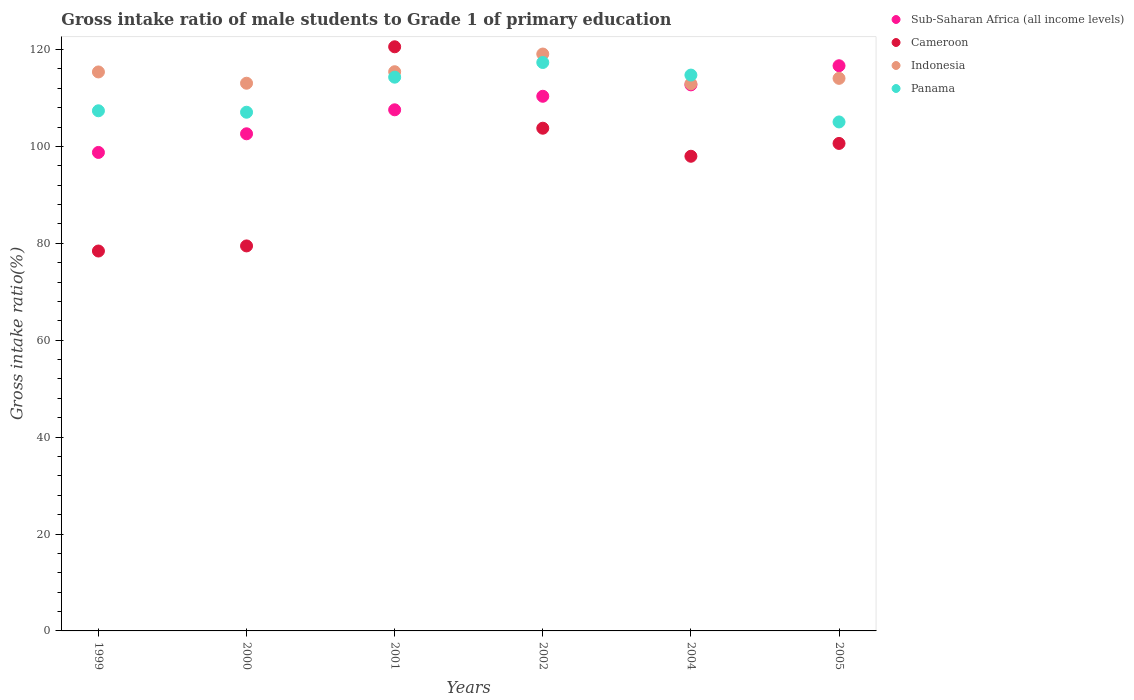How many different coloured dotlines are there?
Keep it short and to the point. 4. What is the gross intake ratio in Indonesia in 1999?
Offer a very short reply. 115.38. Across all years, what is the maximum gross intake ratio in Indonesia?
Make the answer very short. 119.08. Across all years, what is the minimum gross intake ratio in Cameroon?
Keep it short and to the point. 78.41. In which year was the gross intake ratio in Sub-Saharan Africa (all income levels) maximum?
Offer a terse response. 2005. In which year was the gross intake ratio in Sub-Saharan Africa (all income levels) minimum?
Ensure brevity in your answer.  1999. What is the total gross intake ratio in Panama in the graph?
Give a very brief answer. 665.84. What is the difference between the gross intake ratio in Indonesia in 2001 and that in 2005?
Your response must be concise. 1.37. What is the difference between the gross intake ratio in Cameroon in 2002 and the gross intake ratio in Panama in 2000?
Provide a short and direct response. -3.3. What is the average gross intake ratio in Sub-Saharan Africa (all income levels) per year?
Provide a succinct answer. 108.11. In the year 2000, what is the difference between the gross intake ratio in Cameroon and gross intake ratio in Panama?
Your answer should be compact. -27.6. What is the ratio of the gross intake ratio in Panama in 2001 to that in 2004?
Provide a short and direct response. 1. Is the gross intake ratio in Indonesia in 2002 less than that in 2005?
Ensure brevity in your answer.  No. Is the difference between the gross intake ratio in Cameroon in 2002 and 2005 greater than the difference between the gross intake ratio in Panama in 2002 and 2005?
Provide a short and direct response. No. What is the difference between the highest and the second highest gross intake ratio in Cameroon?
Provide a succinct answer. 16.81. What is the difference between the highest and the lowest gross intake ratio in Sub-Saharan Africa (all income levels)?
Ensure brevity in your answer.  17.89. In how many years, is the gross intake ratio in Sub-Saharan Africa (all income levels) greater than the average gross intake ratio in Sub-Saharan Africa (all income levels) taken over all years?
Make the answer very short. 3. Is it the case that in every year, the sum of the gross intake ratio in Panama and gross intake ratio in Cameroon  is greater than the sum of gross intake ratio in Sub-Saharan Africa (all income levels) and gross intake ratio in Indonesia?
Ensure brevity in your answer.  No. Is it the case that in every year, the sum of the gross intake ratio in Panama and gross intake ratio in Cameroon  is greater than the gross intake ratio in Indonesia?
Provide a short and direct response. Yes. Is the gross intake ratio in Cameroon strictly greater than the gross intake ratio in Sub-Saharan Africa (all income levels) over the years?
Offer a very short reply. No. Are the values on the major ticks of Y-axis written in scientific E-notation?
Keep it short and to the point. No. What is the title of the graph?
Offer a terse response. Gross intake ratio of male students to Grade 1 of primary education. Does "Chile" appear as one of the legend labels in the graph?
Your answer should be very brief. No. What is the label or title of the Y-axis?
Your answer should be compact. Gross intake ratio(%). What is the Gross intake ratio(%) in Sub-Saharan Africa (all income levels) in 1999?
Your answer should be compact. 98.76. What is the Gross intake ratio(%) of Cameroon in 1999?
Keep it short and to the point. 78.41. What is the Gross intake ratio(%) in Indonesia in 1999?
Your response must be concise. 115.38. What is the Gross intake ratio(%) in Panama in 1999?
Ensure brevity in your answer.  107.36. What is the Gross intake ratio(%) in Sub-Saharan Africa (all income levels) in 2000?
Your answer should be very brief. 102.61. What is the Gross intake ratio(%) in Cameroon in 2000?
Give a very brief answer. 79.47. What is the Gross intake ratio(%) of Indonesia in 2000?
Provide a short and direct response. 113.05. What is the Gross intake ratio(%) of Panama in 2000?
Your response must be concise. 107.06. What is the Gross intake ratio(%) of Sub-Saharan Africa (all income levels) in 2001?
Ensure brevity in your answer.  107.56. What is the Gross intake ratio(%) in Cameroon in 2001?
Your answer should be very brief. 120.57. What is the Gross intake ratio(%) in Indonesia in 2001?
Provide a succinct answer. 115.42. What is the Gross intake ratio(%) in Panama in 2001?
Offer a very short reply. 114.3. What is the Gross intake ratio(%) in Sub-Saharan Africa (all income levels) in 2002?
Ensure brevity in your answer.  110.36. What is the Gross intake ratio(%) in Cameroon in 2002?
Provide a short and direct response. 103.76. What is the Gross intake ratio(%) of Indonesia in 2002?
Keep it short and to the point. 119.08. What is the Gross intake ratio(%) of Panama in 2002?
Give a very brief answer. 117.33. What is the Gross intake ratio(%) in Sub-Saharan Africa (all income levels) in 2004?
Your response must be concise. 112.71. What is the Gross intake ratio(%) of Cameroon in 2004?
Your answer should be compact. 97.98. What is the Gross intake ratio(%) of Indonesia in 2004?
Ensure brevity in your answer.  112.94. What is the Gross intake ratio(%) in Panama in 2004?
Your response must be concise. 114.73. What is the Gross intake ratio(%) of Sub-Saharan Africa (all income levels) in 2005?
Offer a very short reply. 116.66. What is the Gross intake ratio(%) in Cameroon in 2005?
Your answer should be compact. 100.62. What is the Gross intake ratio(%) of Indonesia in 2005?
Make the answer very short. 114.06. What is the Gross intake ratio(%) in Panama in 2005?
Ensure brevity in your answer.  105.06. Across all years, what is the maximum Gross intake ratio(%) in Sub-Saharan Africa (all income levels)?
Your answer should be compact. 116.66. Across all years, what is the maximum Gross intake ratio(%) of Cameroon?
Your answer should be very brief. 120.57. Across all years, what is the maximum Gross intake ratio(%) in Indonesia?
Your answer should be very brief. 119.08. Across all years, what is the maximum Gross intake ratio(%) in Panama?
Ensure brevity in your answer.  117.33. Across all years, what is the minimum Gross intake ratio(%) of Sub-Saharan Africa (all income levels)?
Offer a very short reply. 98.76. Across all years, what is the minimum Gross intake ratio(%) of Cameroon?
Offer a terse response. 78.41. Across all years, what is the minimum Gross intake ratio(%) of Indonesia?
Give a very brief answer. 112.94. Across all years, what is the minimum Gross intake ratio(%) in Panama?
Offer a terse response. 105.06. What is the total Gross intake ratio(%) in Sub-Saharan Africa (all income levels) in the graph?
Offer a terse response. 648.66. What is the total Gross intake ratio(%) in Cameroon in the graph?
Provide a succinct answer. 580.81. What is the total Gross intake ratio(%) of Indonesia in the graph?
Your answer should be very brief. 689.92. What is the total Gross intake ratio(%) in Panama in the graph?
Provide a succinct answer. 665.84. What is the difference between the Gross intake ratio(%) of Sub-Saharan Africa (all income levels) in 1999 and that in 2000?
Offer a very short reply. -3.85. What is the difference between the Gross intake ratio(%) in Cameroon in 1999 and that in 2000?
Your response must be concise. -1.05. What is the difference between the Gross intake ratio(%) of Indonesia in 1999 and that in 2000?
Make the answer very short. 2.33. What is the difference between the Gross intake ratio(%) of Panama in 1999 and that in 2000?
Provide a short and direct response. 0.3. What is the difference between the Gross intake ratio(%) of Sub-Saharan Africa (all income levels) in 1999 and that in 2001?
Make the answer very short. -8.8. What is the difference between the Gross intake ratio(%) in Cameroon in 1999 and that in 2001?
Make the answer very short. -42.16. What is the difference between the Gross intake ratio(%) of Indonesia in 1999 and that in 2001?
Your answer should be very brief. -0.05. What is the difference between the Gross intake ratio(%) in Panama in 1999 and that in 2001?
Offer a terse response. -6.94. What is the difference between the Gross intake ratio(%) in Sub-Saharan Africa (all income levels) in 1999 and that in 2002?
Give a very brief answer. -11.59. What is the difference between the Gross intake ratio(%) of Cameroon in 1999 and that in 2002?
Your response must be concise. -25.35. What is the difference between the Gross intake ratio(%) in Indonesia in 1999 and that in 2002?
Provide a succinct answer. -3.7. What is the difference between the Gross intake ratio(%) in Panama in 1999 and that in 2002?
Offer a terse response. -9.97. What is the difference between the Gross intake ratio(%) of Sub-Saharan Africa (all income levels) in 1999 and that in 2004?
Make the answer very short. -13.95. What is the difference between the Gross intake ratio(%) in Cameroon in 1999 and that in 2004?
Keep it short and to the point. -19.56. What is the difference between the Gross intake ratio(%) of Indonesia in 1999 and that in 2004?
Provide a succinct answer. 2.44. What is the difference between the Gross intake ratio(%) of Panama in 1999 and that in 2004?
Your answer should be very brief. -7.37. What is the difference between the Gross intake ratio(%) in Sub-Saharan Africa (all income levels) in 1999 and that in 2005?
Provide a short and direct response. -17.89. What is the difference between the Gross intake ratio(%) in Cameroon in 1999 and that in 2005?
Provide a short and direct response. -22.21. What is the difference between the Gross intake ratio(%) in Indonesia in 1999 and that in 2005?
Offer a very short reply. 1.32. What is the difference between the Gross intake ratio(%) of Panama in 1999 and that in 2005?
Offer a terse response. 2.31. What is the difference between the Gross intake ratio(%) in Sub-Saharan Africa (all income levels) in 2000 and that in 2001?
Offer a terse response. -4.95. What is the difference between the Gross intake ratio(%) of Cameroon in 2000 and that in 2001?
Provide a short and direct response. -41.1. What is the difference between the Gross intake ratio(%) of Indonesia in 2000 and that in 2001?
Your answer should be very brief. -2.37. What is the difference between the Gross intake ratio(%) of Panama in 2000 and that in 2001?
Ensure brevity in your answer.  -7.24. What is the difference between the Gross intake ratio(%) of Sub-Saharan Africa (all income levels) in 2000 and that in 2002?
Make the answer very short. -7.74. What is the difference between the Gross intake ratio(%) of Cameroon in 2000 and that in 2002?
Offer a terse response. -24.3. What is the difference between the Gross intake ratio(%) in Indonesia in 2000 and that in 2002?
Keep it short and to the point. -6.03. What is the difference between the Gross intake ratio(%) in Panama in 2000 and that in 2002?
Your answer should be very brief. -10.27. What is the difference between the Gross intake ratio(%) of Sub-Saharan Africa (all income levels) in 2000 and that in 2004?
Offer a very short reply. -10.1. What is the difference between the Gross intake ratio(%) in Cameroon in 2000 and that in 2004?
Give a very brief answer. -18.51. What is the difference between the Gross intake ratio(%) of Indonesia in 2000 and that in 2004?
Your answer should be compact. 0.11. What is the difference between the Gross intake ratio(%) of Panama in 2000 and that in 2004?
Give a very brief answer. -7.67. What is the difference between the Gross intake ratio(%) of Sub-Saharan Africa (all income levels) in 2000 and that in 2005?
Your response must be concise. -14.04. What is the difference between the Gross intake ratio(%) of Cameroon in 2000 and that in 2005?
Give a very brief answer. -21.15. What is the difference between the Gross intake ratio(%) of Indonesia in 2000 and that in 2005?
Provide a short and direct response. -1.01. What is the difference between the Gross intake ratio(%) in Panama in 2000 and that in 2005?
Keep it short and to the point. 2.01. What is the difference between the Gross intake ratio(%) of Sub-Saharan Africa (all income levels) in 2001 and that in 2002?
Keep it short and to the point. -2.79. What is the difference between the Gross intake ratio(%) in Cameroon in 2001 and that in 2002?
Your response must be concise. 16.81. What is the difference between the Gross intake ratio(%) in Indonesia in 2001 and that in 2002?
Your response must be concise. -3.65. What is the difference between the Gross intake ratio(%) of Panama in 2001 and that in 2002?
Make the answer very short. -3.03. What is the difference between the Gross intake ratio(%) in Sub-Saharan Africa (all income levels) in 2001 and that in 2004?
Provide a short and direct response. -5.15. What is the difference between the Gross intake ratio(%) of Cameroon in 2001 and that in 2004?
Give a very brief answer. 22.6. What is the difference between the Gross intake ratio(%) in Indonesia in 2001 and that in 2004?
Give a very brief answer. 2.48. What is the difference between the Gross intake ratio(%) in Panama in 2001 and that in 2004?
Your answer should be very brief. -0.43. What is the difference between the Gross intake ratio(%) in Sub-Saharan Africa (all income levels) in 2001 and that in 2005?
Provide a succinct answer. -9.09. What is the difference between the Gross intake ratio(%) in Cameroon in 2001 and that in 2005?
Your answer should be very brief. 19.95. What is the difference between the Gross intake ratio(%) in Indonesia in 2001 and that in 2005?
Your answer should be compact. 1.37. What is the difference between the Gross intake ratio(%) in Panama in 2001 and that in 2005?
Your response must be concise. 9.24. What is the difference between the Gross intake ratio(%) in Sub-Saharan Africa (all income levels) in 2002 and that in 2004?
Ensure brevity in your answer.  -2.35. What is the difference between the Gross intake ratio(%) of Cameroon in 2002 and that in 2004?
Provide a short and direct response. 5.79. What is the difference between the Gross intake ratio(%) of Indonesia in 2002 and that in 2004?
Provide a succinct answer. 6.14. What is the difference between the Gross intake ratio(%) in Panama in 2002 and that in 2004?
Ensure brevity in your answer.  2.6. What is the difference between the Gross intake ratio(%) in Sub-Saharan Africa (all income levels) in 2002 and that in 2005?
Give a very brief answer. -6.3. What is the difference between the Gross intake ratio(%) of Cameroon in 2002 and that in 2005?
Provide a succinct answer. 3.14. What is the difference between the Gross intake ratio(%) of Indonesia in 2002 and that in 2005?
Keep it short and to the point. 5.02. What is the difference between the Gross intake ratio(%) of Panama in 2002 and that in 2005?
Give a very brief answer. 12.27. What is the difference between the Gross intake ratio(%) of Sub-Saharan Africa (all income levels) in 2004 and that in 2005?
Make the answer very short. -3.95. What is the difference between the Gross intake ratio(%) in Cameroon in 2004 and that in 2005?
Ensure brevity in your answer.  -2.65. What is the difference between the Gross intake ratio(%) in Indonesia in 2004 and that in 2005?
Provide a short and direct response. -1.12. What is the difference between the Gross intake ratio(%) in Panama in 2004 and that in 2005?
Your answer should be compact. 9.67. What is the difference between the Gross intake ratio(%) in Sub-Saharan Africa (all income levels) in 1999 and the Gross intake ratio(%) in Cameroon in 2000?
Offer a terse response. 19.3. What is the difference between the Gross intake ratio(%) in Sub-Saharan Africa (all income levels) in 1999 and the Gross intake ratio(%) in Indonesia in 2000?
Make the answer very short. -14.29. What is the difference between the Gross intake ratio(%) in Sub-Saharan Africa (all income levels) in 1999 and the Gross intake ratio(%) in Panama in 2000?
Provide a succinct answer. -8.3. What is the difference between the Gross intake ratio(%) of Cameroon in 1999 and the Gross intake ratio(%) of Indonesia in 2000?
Make the answer very short. -34.64. What is the difference between the Gross intake ratio(%) in Cameroon in 1999 and the Gross intake ratio(%) in Panama in 2000?
Keep it short and to the point. -28.65. What is the difference between the Gross intake ratio(%) in Indonesia in 1999 and the Gross intake ratio(%) in Panama in 2000?
Provide a succinct answer. 8.31. What is the difference between the Gross intake ratio(%) of Sub-Saharan Africa (all income levels) in 1999 and the Gross intake ratio(%) of Cameroon in 2001?
Provide a succinct answer. -21.81. What is the difference between the Gross intake ratio(%) in Sub-Saharan Africa (all income levels) in 1999 and the Gross intake ratio(%) in Indonesia in 2001?
Provide a succinct answer. -16.66. What is the difference between the Gross intake ratio(%) in Sub-Saharan Africa (all income levels) in 1999 and the Gross intake ratio(%) in Panama in 2001?
Offer a terse response. -15.53. What is the difference between the Gross intake ratio(%) in Cameroon in 1999 and the Gross intake ratio(%) in Indonesia in 2001?
Give a very brief answer. -37.01. What is the difference between the Gross intake ratio(%) of Cameroon in 1999 and the Gross intake ratio(%) of Panama in 2001?
Give a very brief answer. -35.88. What is the difference between the Gross intake ratio(%) of Indonesia in 1999 and the Gross intake ratio(%) of Panama in 2001?
Give a very brief answer. 1.08. What is the difference between the Gross intake ratio(%) in Sub-Saharan Africa (all income levels) in 1999 and the Gross intake ratio(%) in Cameroon in 2002?
Your response must be concise. -5. What is the difference between the Gross intake ratio(%) of Sub-Saharan Africa (all income levels) in 1999 and the Gross intake ratio(%) of Indonesia in 2002?
Your answer should be compact. -20.31. What is the difference between the Gross intake ratio(%) of Sub-Saharan Africa (all income levels) in 1999 and the Gross intake ratio(%) of Panama in 2002?
Make the answer very short. -18.56. What is the difference between the Gross intake ratio(%) in Cameroon in 1999 and the Gross intake ratio(%) in Indonesia in 2002?
Your answer should be compact. -40.66. What is the difference between the Gross intake ratio(%) in Cameroon in 1999 and the Gross intake ratio(%) in Panama in 2002?
Offer a terse response. -38.91. What is the difference between the Gross intake ratio(%) in Indonesia in 1999 and the Gross intake ratio(%) in Panama in 2002?
Provide a short and direct response. -1.95. What is the difference between the Gross intake ratio(%) of Sub-Saharan Africa (all income levels) in 1999 and the Gross intake ratio(%) of Cameroon in 2004?
Your response must be concise. 0.79. What is the difference between the Gross intake ratio(%) of Sub-Saharan Africa (all income levels) in 1999 and the Gross intake ratio(%) of Indonesia in 2004?
Your answer should be compact. -14.17. What is the difference between the Gross intake ratio(%) of Sub-Saharan Africa (all income levels) in 1999 and the Gross intake ratio(%) of Panama in 2004?
Keep it short and to the point. -15.97. What is the difference between the Gross intake ratio(%) of Cameroon in 1999 and the Gross intake ratio(%) of Indonesia in 2004?
Ensure brevity in your answer.  -34.52. What is the difference between the Gross intake ratio(%) in Cameroon in 1999 and the Gross intake ratio(%) in Panama in 2004?
Your response must be concise. -36.32. What is the difference between the Gross intake ratio(%) of Indonesia in 1999 and the Gross intake ratio(%) of Panama in 2004?
Offer a terse response. 0.65. What is the difference between the Gross intake ratio(%) in Sub-Saharan Africa (all income levels) in 1999 and the Gross intake ratio(%) in Cameroon in 2005?
Make the answer very short. -1.86. What is the difference between the Gross intake ratio(%) of Sub-Saharan Africa (all income levels) in 1999 and the Gross intake ratio(%) of Indonesia in 2005?
Give a very brief answer. -15.29. What is the difference between the Gross intake ratio(%) in Sub-Saharan Africa (all income levels) in 1999 and the Gross intake ratio(%) in Panama in 2005?
Your response must be concise. -6.29. What is the difference between the Gross intake ratio(%) of Cameroon in 1999 and the Gross intake ratio(%) of Indonesia in 2005?
Provide a succinct answer. -35.64. What is the difference between the Gross intake ratio(%) in Cameroon in 1999 and the Gross intake ratio(%) in Panama in 2005?
Give a very brief answer. -26.64. What is the difference between the Gross intake ratio(%) in Indonesia in 1999 and the Gross intake ratio(%) in Panama in 2005?
Your answer should be compact. 10.32. What is the difference between the Gross intake ratio(%) of Sub-Saharan Africa (all income levels) in 2000 and the Gross intake ratio(%) of Cameroon in 2001?
Make the answer very short. -17.96. What is the difference between the Gross intake ratio(%) in Sub-Saharan Africa (all income levels) in 2000 and the Gross intake ratio(%) in Indonesia in 2001?
Provide a succinct answer. -12.81. What is the difference between the Gross intake ratio(%) of Sub-Saharan Africa (all income levels) in 2000 and the Gross intake ratio(%) of Panama in 2001?
Your answer should be very brief. -11.68. What is the difference between the Gross intake ratio(%) in Cameroon in 2000 and the Gross intake ratio(%) in Indonesia in 2001?
Offer a terse response. -35.95. What is the difference between the Gross intake ratio(%) in Cameroon in 2000 and the Gross intake ratio(%) in Panama in 2001?
Ensure brevity in your answer.  -34.83. What is the difference between the Gross intake ratio(%) of Indonesia in 2000 and the Gross intake ratio(%) of Panama in 2001?
Provide a short and direct response. -1.25. What is the difference between the Gross intake ratio(%) in Sub-Saharan Africa (all income levels) in 2000 and the Gross intake ratio(%) in Cameroon in 2002?
Ensure brevity in your answer.  -1.15. What is the difference between the Gross intake ratio(%) of Sub-Saharan Africa (all income levels) in 2000 and the Gross intake ratio(%) of Indonesia in 2002?
Keep it short and to the point. -16.46. What is the difference between the Gross intake ratio(%) of Sub-Saharan Africa (all income levels) in 2000 and the Gross intake ratio(%) of Panama in 2002?
Offer a very short reply. -14.71. What is the difference between the Gross intake ratio(%) of Cameroon in 2000 and the Gross intake ratio(%) of Indonesia in 2002?
Provide a succinct answer. -39.61. What is the difference between the Gross intake ratio(%) in Cameroon in 2000 and the Gross intake ratio(%) in Panama in 2002?
Your answer should be compact. -37.86. What is the difference between the Gross intake ratio(%) of Indonesia in 2000 and the Gross intake ratio(%) of Panama in 2002?
Offer a terse response. -4.28. What is the difference between the Gross intake ratio(%) of Sub-Saharan Africa (all income levels) in 2000 and the Gross intake ratio(%) of Cameroon in 2004?
Offer a very short reply. 4.64. What is the difference between the Gross intake ratio(%) in Sub-Saharan Africa (all income levels) in 2000 and the Gross intake ratio(%) in Indonesia in 2004?
Your response must be concise. -10.32. What is the difference between the Gross intake ratio(%) of Sub-Saharan Africa (all income levels) in 2000 and the Gross intake ratio(%) of Panama in 2004?
Offer a terse response. -12.12. What is the difference between the Gross intake ratio(%) of Cameroon in 2000 and the Gross intake ratio(%) of Indonesia in 2004?
Provide a succinct answer. -33.47. What is the difference between the Gross intake ratio(%) in Cameroon in 2000 and the Gross intake ratio(%) in Panama in 2004?
Your response must be concise. -35.26. What is the difference between the Gross intake ratio(%) of Indonesia in 2000 and the Gross intake ratio(%) of Panama in 2004?
Provide a short and direct response. -1.68. What is the difference between the Gross intake ratio(%) of Sub-Saharan Africa (all income levels) in 2000 and the Gross intake ratio(%) of Cameroon in 2005?
Your response must be concise. 1.99. What is the difference between the Gross intake ratio(%) in Sub-Saharan Africa (all income levels) in 2000 and the Gross intake ratio(%) in Indonesia in 2005?
Offer a very short reply. -11.44. What is the difference between the Gross intake ratio(%) of Sub-Saharan Africa (all income levels) in 2000 and the Gross intake ratio(%) of Panama in 2005?
Keep it short and to the point. -2.44. What is the difference between the Gross intake ratio(%) of Cameroon in 2000 and the Gross intake ratio(%) of Indonesia in 2005?
Offer a terse response. -34.59. What is the difference between the Gross intake ratio(%) in Cameroon in 2000 and the Gross intake ratio(%) in Panama in 2005?
Provide a succinct answer. -25.59. What is the difference between the Gross intake ratio(%) in Indonesia in 2000 and the Gross intake ratio(%) in Panama in 2005?
Offer a very short reply. 7.99. What is the difference between the Gross intake ratio(%) of Sub-Saharan Africa (all income levels) in 2001 and the Gross intake ratio(%) of Cameroon in 2002?
Your answer should be very brief. 3.8. What is the difference between the Gross intake ratio(%) of Sub-Saharan Africa (all income levels) in 2001 and the Gross intake ratio(%) of Indonesia in 2002?
Your answer should be compact. -11.51. What is the difference between the Gross intake ratio(%) in Sub-Saharan Africa (all income levels) in 2001 and the Gross intake ratio(%) in Panama in 2002?
Give a very brief answer. -9.77. What is the difference between the Gross intake ratio(%) of Cameroon in 2001 and the Gross intake ratio(%) of Indonesia in 2002?
Provide a succinct answer. 1.5. What is the difference between the Gross intake ratio(%) of Cameroon in 2001 and the Gross intake ratio(%) of Panama in 2002?
Your answer should be very brief. 3.24. What is the difference between the Gross intake ratio(%) of Indonesia in 2001 and the Gross intake ratio(%) of Panama in 2002?
Keep it short and to the point. -1.91. What is the difference between the Gross intake ratio(%) of Sub-Saharan Africa (all income levels) in 2001 and the Gross intake ratio(%) of Cameroon in 2004?
Your answer should be compact. 9.59. What is the difference between the Gross intake ratio(%) in Sub-Saharan Africa (all income levels) in 2001 and the Gross intake ratio(%) in Indonesia in 2004?
Your answer should be very brief. -5.37. What is the difference between the Gross intake ratio(%) of Sub-Saharan Africa (all income levels) in 2001 and the Gross intake ratio(%) of Panama in 2004?
Provide a succinct answer. -7.17. What is the difference between the Gross intake ratio(%) of Cameroon in 2001 and the Gross intake ratio(%) of Indonesia in 2004?
Keep it short and to the point. 7.63. What is the difference between the Gross intake ratio(%) in Cameroon in 2001 and the Gross intake ratio(%) in Panama in 2004?
Provide a succinct answer. 5.84. What is the difference between the Gross intake ratio(%) in Indonesia in 2001 and the Gross intake ratio(%) in Panama in 2004?
Offer a very short reply. 0.69. What is the difference between the Gross intake ratio(%) in Sub-Saharan Africa (all income levels) in 2001 and the Gross intake ratio(%) in Cameroon in 2005?
Make the answer very short. 6.94. What is the difference between the Gross intake ratio(%) in Sub-Saharan Africa (all income levels) in 2001 and the Gross intake ratio(%) in Indonesia in 2005?
Keep it short and to the point. -6.49. What is the difference between the Gross intake ratio(%) of Sub-Saharan Africa (all income levels) in 2001 and the Gross intake ratio(%) of Panama in 2005?
Your answer should be compact. 2.51. What is the difference between the Gross intake ratio(%) of Cameroon in 2001 and the Gross intake ratio(%) of Indonesia in 2005?
Keep it short and to the point. 6.52. What is the difference between the Gross intake ratio(%) in Cameroon in 2001 and the Gross intake ratio(%) in Panama in 2005?
Your response must be concise. 15.51. What is the difference between the Gross intake ratio(%) of Indonesia in 2001 and the Gross intake ratio(%) of Panama in 2005?
Your answer should be very brief. 10.37. What is the difference between the Gross intake ratio(%) in Sub-Saharan Africa (all income levels) in 2002 and the Gross intake ratio(%) in Cameroon in 2004?
Give a very brief answer. 12.38. What is the difference between the Gross intake ratio(%) in Sub-Saharan Africa (all income levels) in 2002 and the Gross intake ratio(%) in Indonesia in 2004?
Give a very brief answer. -2.58. What is the difference between the Gross intake ratio(%) in Sub-Saharan Africa (all income levels) in 2002 and the Gross intake ratio(%) in Panama in 2004?
Offer a terse response. -4.37. What is the difference between the Gross intake ratio(%) in Cameroon in 2002 and the Gross intake ratio(%) in Indonesia in 2004?
Ensure brevity in your answer.  -9.17. What is the difference between the Gross intake ratio(%) of Cameroon in 2002 and the Gross intake ratio(%) of Panama in 2004?
Your answer should be compact. -10.97. What is the difference between the Gross intake ratio(%) in Indonesia in 2002 and the Gross intake ratio(%) in Panama in 2004?
Your answer should be compact. 4.34. What is the difference between the Gross intake ratio(%) of Sub-Saharan Africa (all income levels) in 2002 and the Gross intake ratio(%) of Cameroon in 2005?
Your answer should be compact. 9.73. What is the difference between the Gross intake ratio(%) of Sub-Saharan Africa (all income levels) in 2002 and the Gross intake ratio(%) of Indonesia in 2005?
Offer a very short reply. -3.7. What is the difference between the Gross intake ratio(%) of Sub-Saharan Africa (all income levels) in 2002 and the Gross intake ratio(%) of Panama in 2005?
Ensure brevity in your answer.  5.3. What is the difference between the Gross intake ratio(%) of Cameroon in 2002 and the Gross intake ratio(%) of Indonesia in 2005?
Your response must be concise. -10.29. What is the difference between the Gross intake ratio(%) of Cameroon in 2002 and the Gross intake ratio(%) of Panama in 2005?
Ensure brevity in your answer.  -1.29. What is the difference between the Gross intake ratio(%) of Indonesia in 2002 and the Gross intake ratio(%) of Panama in 2005?
Offer a terse response. 14.02. What is the difference between the Gross intake ratio(%) in Sub-Saharan Africa (all income levels) in 2004 and the Gross intake ratio(%) in Cameroon in 2005?
Make the answer very short. 12.09. What is the difference between the Gross intake ratio(%) in Sub-Saharan Africa (all income levels) in 2004 and the Gross intake ratio(%) in Indonesia in 2005?
Your answer should be compact. -1.35. What is the difference between the Gross intake ratio(%) of Sub-Saharan Africa (all income levels) in 2004 and the Gross intake ratio(%) of Panama in 2005?
Your response must be concise. 7.65. What is the difference between the Gross intake ratio(%) of Cameroon in 2004 and the Gross intake ratio(%) of Indonesia in 2005?
Offer a terse response. -16.08. What is the difference between the Gross intake ratio(%) of Cameroon in 2004 and the Gross intake ratio(%) of Panama in 2005?
Ensure brevity in your answer.  -7.08. What is the difference between the Gross intake ratio(%) of Indonesia in 2004 and the Gross intake ratio(%) of Panama in 2005?
Keep it short and to the point. 7.88. What is the average Gross intake ratio(%) of Sub-Saharan Africa (all income levels) per year?
Make the answer very short. 108.11. What is the average Gross intake ratio(%) in Cameroon per year?
Ensure brevity in your answer.  96.8. What is the average Gross intake ratio(%) in Indonesia per year?
Keep it short and to the point. 114.99. What is the average Gross intake ratio(%) of Panama per year?
Your response must be concise. 110.97. In the year 1999, what is the difference between the Gross intake ratio(%) in Sub-Saharan Africa (all income levels) and Gross intake ratio(%) in Cameroon?
Your response must be concise. 20.35. In the year 1999, what is the difference between the Gross intake ratio(%) in Sub-Saharan Africa (all income levels) and Gross intake ratio(%) in Indonesia?
Keep it short and to the point. -16.61. In the year 1999, what is the difference between the Gross intake ratio(%) of Sub-Saharan Africa (all income levels) and Gross intake ratio(%) of Panama?
Keep it short and to the point. -8.6. In the year 1999, what is the difference between the Gross intake ratio(%) of Cameroon and Gross intake ratio(%) of Indonesia?
Keep it short and to the point. -36.96. In the year 1999, what is the difference between the Gross intake ratio(%) of Cameroon and Gross intake ratio(%) of Panama?
Ensure brevity in your answer.  -28.95. In the year 1999, what is the difference between the Gross intake ratio(%) of Indonesia and Gross intake ratio(%) of Panama?
Ensure brevity in your answer.  8.02. In the year 2000, what is the difference between the Gross intake ratio(%) in Sub-Saharan Africa (all income levels) and Gross intake ratio(%) in Cameroon?
Offer a very short reply. 23.15. In the year 2000, what is the difference between the Gross intake ratio(%) of Sub-Saharan Africa (all income levels) and Gross intake ratio(%) of Indonesia?
Give a very brief answer. -10.44. In the year 2000, what is the difference between the Gross intake ratio(%) of Sub-Saharan Africa (all income levels) and Gross intake ratio(%) of Panama?
Keep it short and to the point. -4.45. In the year 2000, what is the difference between the Gross intake ratio(%) of Cameroon and Gross intake ratio(%) of Indonesia?
Your response must be concise. -33.58. In the year 2000, what is the difference between the Gross intake ratio(%) of Cameroon and Gross intake ratio(%) of Panama?
Provide a short and direct response. -27.6. In the year 2000, what is the difference between the Gross intake ratio(%) in Indonesia and Gross intake ratio(%) in Panama?
Keep it short and to the point. 5.99. In the year 2001, what is the difference between the Gross intake ratio(%) of Sub-Saharan Africa (all income levels) and Gross intake ratio(%) of Cameroon?
Give a very brief answer. -13.01. In the year 2001, what is the difference between the Gross intake ratio(%) in Sub-Saharan Africa (all income levels) and Gross intake ratio(%) in Indonesia?
Give a very brief answer. -7.86. In the year 2001, what is the difference between the Gross intake ratio(%) in Sub-Saharan Africa (all income levels) and Gross intake ratio(%) in Panama?
Offer a terse response. -6.74. In the year 2001, what is the difference between the Gross intake ratio(%) of Cameroon and Gross intake ratio(%) of Indonesia?
Offer a terse response. 5.15. In the year 2001, what is the difference between the Gross intake ratio(%) of Cameroon and Gross intake ratio(%) of Panama?
Keep it short and to the point. 6.27. In the year 2001, what is the difference between the Gross intake ratio(%) in Indonesia and Gross intake ratio(%) in Panama?
Make the answer very short. 1.12. In the year 2002, what is the difference between the Gross intake ratio(%) of Sub-Saharan Africa (all income levels) and Gross intake ratio(%) of Cameroon?
Make the answer very short. 6.59. In the year 2002, what is the difference between the Gross intake ratio(%) in Sub-Saharan Africa (all income levels) and Gross intake ratio(%) in Indonesia?
Your response must be concise. -8.72. In the year 2002, what is the difference between the Gross intake ratio(%) in Sub-Saharan Africa (all income levels) and Gross intake ratio(%) in Panama?
Your answer should be compact. -6.97. In the year 2002, what is the difference between the Gross intake ratio(%) in Cameroon and Gross intake ratio(%) in Indonesia?
Your answer should be compact. -15.31. In the year 2002, what is the difference between the Gross intake ratio(%) of Cameroon and Gross intake ratio(%) of Panama?
Your answer should be compact. -13.56. In the year 2002, what is the difference between the Gross intake ratio(%) of Indonesia and Gross intake ratio(%) of Panama?
Provide a succinct answer. 1.75. In the year 2004, what is the difference between the Gross intake ratio(%) of Sub-Saharan Africa (all income levels) and Gross intake ratio(%) of Cameroon?
Offer a very short reply. 14.73. In the year 2004, what is the difference between the Gross intake ratio(%) in Sub-Saharan Africa (all income levels) and Gross intake ratio(%) in Indonesia?
Provide a short and direct response. -0.23. In the year 2004, what is the difference between the Gross intake ratio(%) in Sub-Saharan Africa (all income levels) and Gross intake ratio(%) in Panama?
Offer a very short reply. -2.02. In the year 2004, what is the difference between the Gross intake ratio(%) in Cameroon and Gross intake ratio(%) in Indonesia?
Ensure brevity in your answer.  -14.96. In the year 2004, what is the difference between the Gross intake ratio(%) in Cameroon and Gross intake ratio(%) in Panama?
Your answer should be compact. -16.76. In the year 2004, what is the difference between the Gross intake ratio(%) of Indonesia and Gross intake ratio(%) of Panama?
Give a very brief answer. -1.79. In the year 2005, what is the difference between the Gross intake ratio(%) of Sub-Saharan Africa (all income levels) and Gross intake ratio(%) of Cameroon?
Your answer should be very brief. 16.03. In the year 2005, what is the difference between the Gross intake ratio(%) in Sub-Saharan Africa (all income levels) and Gross intake ratio(%) in Indonesia?
Offer a very short reply. 2.6. In the year 2005, what is the difference between the Gross intake ratio(%) of Sub-Saharan Africa (all income levels) and Gross intake ratio(%) of Panama?
Offer a terse response. 11.6. In the year 2005, what is the difference between the Gross intake ratio(%) of Cameroon and Gross intake ratio(%) of Indonesia?
Your answer should be very brief. -13.43. In the year 2005, what is the difference between the Gross intake ratio(%) of Cameroon and Gross intake ratio(%) of Panama?
Provide a succinct answer. -4.43. In the year 2005, what is the difference between the Gross intake ratio(%) of Indonesia and Gross intake ratio(%) of Panama?
Ensure brevity in your answer.  9. What is the ratio of the Gross intake ratio(%) in Sub-Saharan Africa (all income levels) in 1999 to that in 2000?
Offer a terse response. 0.96. What is the ratio of the Gross intake ratio(%) of Indonesia in 1999 to that in 2000?
Provide a succinct answer. 1.02. What is the ratio of the Gross intake ratio(%) in Panama in 1999 to that in 2000?
Your response must be concise. 1. What is the ratio of the Gross intake ratio(%) of Sub-Saharan Africa (all income levels) in 1999 to that in 2001?
Ensure brevity in your answer.  0.92. What is the ratio of the Gross intake ratio(%) of Cameroon in 1999 to that in 2001?
Ensure brevity in your answer.  0.65. What is the ratio of the Gross intake ratio(%) of Indonesia in 1999 to that in 2001?
Ensure brevity in your answer.  1. What is the ratio of the Gross intake ratio(%) in Panama in 1999 to that in 2001?
Ensure brevity in your answer.  0.94. What is the ratio of the Gross intake ratio(%) in Sub-Saharan Africa (all income levels) in 1999 to that in 2002?
Give a very brief answer. 0.9. What is the ratio of the Gross intake ratio(%) in Cameroon in 1999 to that in 2002?
Provide a short and direct response. 0.76. What is the ratio of the Gross intake ratio(%) of Indonesia in 1999 to that in 2002?
Provide a succinct answer. 0.97. What is the ratio of the Gross intake ratio(%) in Panama in 1999 to that in 2002?
Your answer should be very brief. 0.92. What is the ratio of the Gross intake ratio(%) of Sub-Saharan Africa (all income levels) in 1999 to that in 2004?
Provide a succinct answer. 0.88. What is the ratio of the Gross intake ratio(%) in Cameroon in 1999 to that in 2004?
Offer a terse response. 0.8. What is the ratio of the Gross intake ratio(%) in Indonesia in 1999 to that in 2004?
Provide a short and direct response. 1.02. What is the ratio of the Gross intake ratio(%) of Panama in 1999 to that in 2004?
Offer a terse response. 0.94. What is the ratio of the Gross intake ratio(%) of Sub-Saharan Africa (all income levels) in 1999 to that in 2005?
Your response must be concise. 0.85. What is the ratio of the Gross intake ratio(%) in Cameroon in 1999 to that in 2005?
Provide a succinct answer. 0.78. What is the ratio of the Gross intake ratio(%) in Indonesia in 1999 to that in 2005?
Your response must be concise. 1.01. What is the ratio of the Gross intake ratio(%) of Panama in 1999 to that in 2005?
Your answer should be compact. 1.02. What is the ratio of the Gross intake ratio(%) in Sub-Saharan Africa (all income levels) in 2000 to that in 2001?
Your response must be concise. 0.95. What is the ratio of the Gross intake ratio(%) in Cameroon in 2000 to that in 2001?
Offer a very short reply. 0.66. What is the ratio of the Gross intake ratio(%) in Indonesia in 2000 to that in 2001?
Provide a short and direct response. 0.98. What is the ratio of the Gross intake ratio(%) in Panama in 2000 to that in 2001?
Your answer should be very brief. 0.94. What is the ratio of the Gross intake ratio(%) of Sub-Saharan Africa (all income levels) in 2000 to that in 2002?
Keep it short and to the point. 0.93. What is the ratio of the Gross intake ratio(%) of Cameroon in 2000 to that in 2002?
Your answer should be very brief. 0.77. What is the ratio of the Gross intake ratio(%) in Indonesia in 2000 to that in 2002?
Provide a short and direct response. 0.95. What is the ratio of the Gross intake ratio(%) of Panama in 2000 to that in 2002?
Ensure brevity in your answer.  0.91. What is the ratio of the Gross intake ratio(%) of Sub-Saharan Africa (all income levels) in 2000 to that in 2004?
Ensure brevity in your answer.  0.91. What is the ratio of the Gross intake ratio(%) in Cameroon in 2000 to that in 2004?
Make the answer very short. 0.81. What is the ratio of the Gross intake ratio(%) of Indonesia in 2000 to that in 2004?
Your answer should be very brief. 1. What is the ratio of the Gross intake ratio(%) in Panama in 2000 to that in 2004?
Offer a very short reply. 0.93. What is the ratio of the Gross intake ratio(%) of Sub-Saharan Africa (all income levels) in 2000 to that in 2005?
Your response must be concise. 0.88. What is the ratio of the Gross intake ratio(%) in Cameroon in 2000 to that in 2005?
Your answer should be compact. 0.79. What is the ratio of the Gross intake ratio(%) of Indonesia in 2000 to that in 2005?
Provide a short and direct response. 0.99. What is the ratio of the Gross intake ratio(%) of Panama in 2000 to that in 2005?
Provide a succinct answer. 1.02. What is the ratio of the Gross intake ratio(%) in Sub-Saharan Africa (all income levels) in 2001 to that in 2002?
Your response must be concise. 0.97. What is the ratio of the Gross intake ratio(%) of Cameroon in 2001 to that in 2002?
Provide a short and direct response. 1.16. What is the ratio of the Gross intake ratio(%) in Indonesia in 2001 to that in 2002?
Keep it short and to the point. 0.97. What is the ratio of the Gross intake ratio(%) in Panama in 2001 to that in 2002?
Your response must be concise. 0.97. What is the ratio of the Gross intake ratio(%) in Sub-Saharan Africa (all income levels) in 2001 to that in 2004?
Provide a succinct answer. 0.95. What is the ratio of the Gross intake ratio(%) in Cameroon in 2001 to that in 2004?
Your answer should be compact. 1.23. What is the ratio of the Gross intake ratio(%) of Indonesia in 2001 to that in 2004?
Offer a terse response. 1.02. What is the ratio of the Gross intake ratio(%) of Panama in 2001 to that in 2004?
Your answer should be very brief. 1. What is the ratio of the Gross intake ratio(%) in Sub-Saharan Africa (all income levels) in 2001 to that in 2005?
Offer a very short reply. 0.92. What is the ratio of the Gross intake ratio(%) of Cameroon in 2001 to that in 2005?
Make the answer very short. 1.2. What is the ratio of the Gross intake ratio(%) of Indonesia in 2001 to that in 2005?
Offer a terse response. 1.01. What is the ratio of the Gross intake ratio(%) in Panama in 2001 to that in 2005?
Offer a very short reply. 1.09. What is the ratio of the Gross intake ratio(%) in Sub-Saharan Africa (all income levels) in 2002 to that in 2004?
Ensure brevity in your answer.  0.98. What is the ratio of the Gross intake ratio(%) of Cameroon in 2002 to that in 2004?
Ensure brevity in your answer.  1.06. What is the ratio of the Gross intake ratio(%) of Indonesia in 2002 to that in 2004?
Keep it short and to the point. 1.05. What is the ratio of the Gross intake ratio(%) of Panama in 2002 to that in 2004?
Give a very brief answer. 1.02. What is the ratio of the Gross intake ratio(%) in Sub-Saharan Africa (all income levels) in 2002 to that in 2005?
Make the answer very short. 0.95. What is the ratio of the Gross intake ratio(%) in Cameroon in 2002 to that in 2005?
Your answer should be compact. 1.03. What is the ratio of the Gross intake ratio(%) in Indonesia in 2002 to that in 2005?
Offer a terse response. 1.04. What is the ratio of the Gross intake ratio(%) in Panama in 2002 to that in 2005?
Offer a very short reply. 1.12. What is the ratio of the Gross intake ratio(%) in Sub-Saharan Africa (all income levels) in 2004 to that in 2005?
Offer a terse response. 0.97. What is the ratio of the Gross intake ratio(%) in Cameroon in 2004 to that in 2005?
Keep it short and to the point. 0.97. What is the ratio of the Gross intake ratio(%) of Indonesia in 2004 to that in 2005?
Make the answer very short. 0.99. What is the ratio of the Gross intake ratio(%) in Panama in 2004 to that in 2005?
Make the answer very short. 1.09. What is the difference between the highest and the second highest Gross intake ratio(%) in Sub-Saharan Africa (all income levels)?
Keep it short and to the point. 3.95. What is the difference between the highest and the second highest Gross intake ratio(%) in Cameroon?
Provide a succinct answer. 16.81. What is the difference between the highest and the second highest Gross intake ratio(%) in Indonesia?
Give a very brief answer. 3.65. What is the difference between the highest and the second highest Gross intake ratio(%) of Panama?
Ensure brevity in your answer.  2.6. What is the difference between the highest and the lowest Gross intake ratio(%) of Sub-Saharan Africa (all income levels)?
Offer a terse response. 17.89. What is the difference between the highest and the lowest Gross intake ratio(%) in Cameroon?
Give a very brief answer. 42.16. What is the difference between the highest and the lowest Gross intake ratio(%) of Indonesia?
Provide a short and direct response. 6.14. What is the difference between the highest and the lowest Gross intake ratio(%) in Panama?
Give a very brief answer. 12.27. 